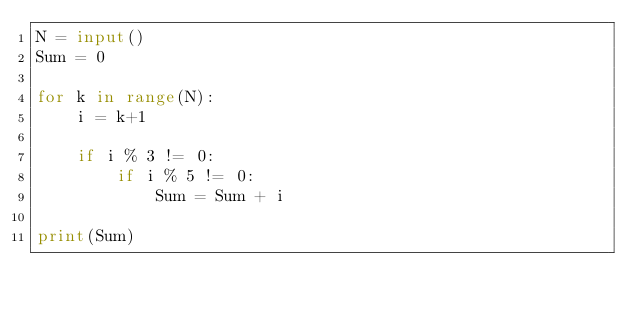Convert code to text. <code><loc_0><loc_0><loc_500><loc_500><_Python_>N = input()
Sum = 0

for k in range(N):
    i = k+1

    if i % 3 != 0:
        if i % 5 != 0:
            Sum = Sum + i

print(Sum)</code> 